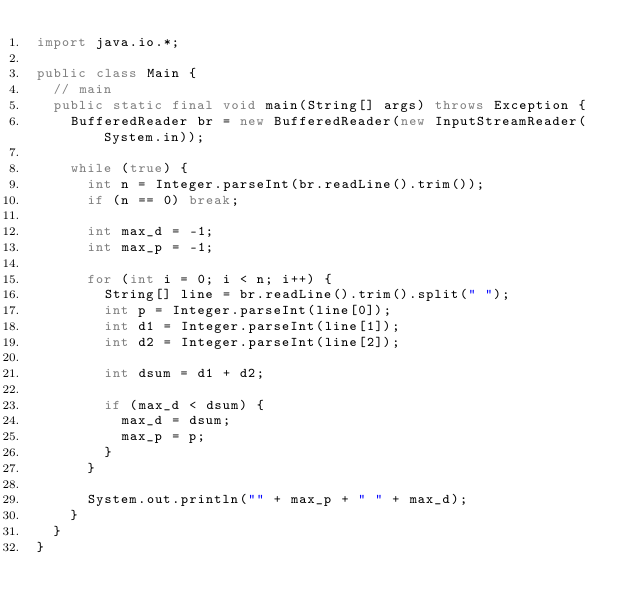<code> <loc_0><loc_0><loc_500><loc_500><_Java_>import java.io.*;

public class Main {
  // main
  public static final void main(String[] args) throws Exception {
    BufferedReader br = new BufferedReader(new InputStreamReader(System.in));

    while (true) {
      int n = Integer.parseInt(br.readLine().trim());
      if (n == 0) break;

      int max_d = -1;
      int max_p = -1;

      for (int i = 0; i < n; i++) {
        String[] line = br.readLine().trim().split(" ");
        int p = Integer.parseInt(line[0]);
        int d1 = Integer.parseInt(line[1]);
        int d2 = Integer.parseInt(line[2]);

        int dsum = d1 + d2;

        if (max_d < dsum) {
          max_d = dsum;
          max_p = p;
        }
      }

      System.out.println("" + max_p + " " + max_d);
    }
  }
}</code> 